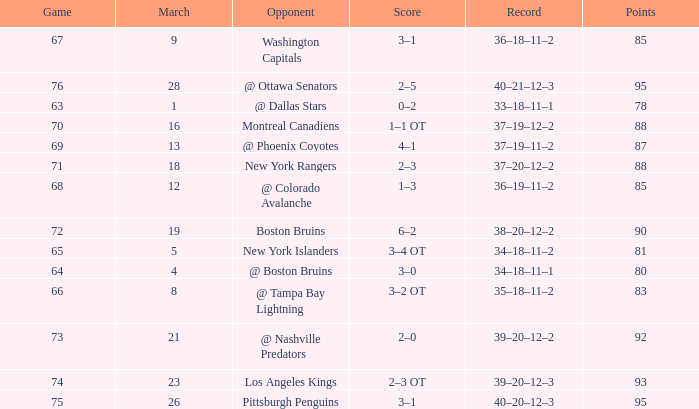Which Points have an Opponent of new york islanders, and a Game smaller than 65? None. 